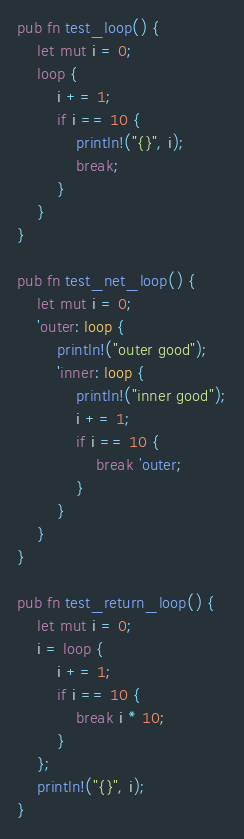<code> <loc_0><loc_0><loc_500><loc_500><_Rust_>pub fn test_loop() {
    let mut i = 0;
    loop {
        i += 1;
        if i == 10 {
            println!("{}", i);
            break;
        }
    }
}

pub fn test_net_loop() {
    let mut i = 0;
    'outer: loop {
        println!("outer good");
        'inner: loop {
            println!("inner good");
            i += 1;
            if i == 10 {
                break 'outer;
            }
        }
    }
}

pub fn test_return_loop() {
    let mut i = 0;
    i = loop {
        i += 1;
        if i == 10 {
            break i * 10;
        }
    };
    println!("{}", i);
}
</code> 